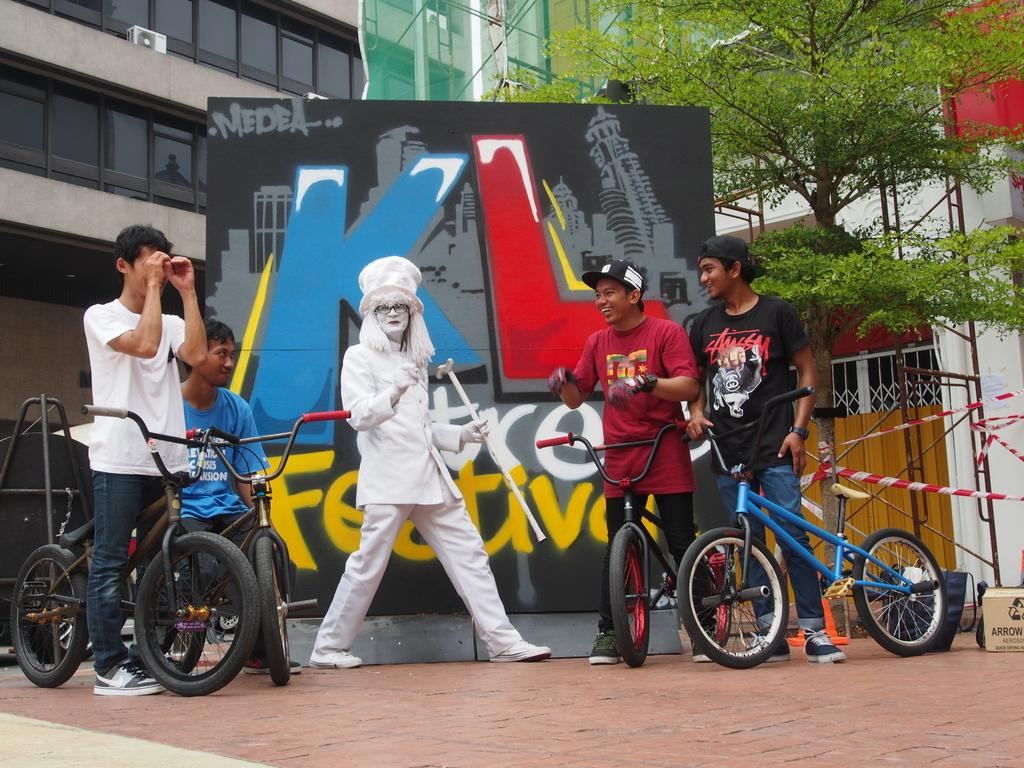What is happening in the image involving a bicycle? There are guys on a bicycle in the image. Can you describe the lady in the image? The lady in the image is wearing a white coat. What else can be seen in the image besides the people and bicycle? There is a poster in the image. What is the name of the poster? The poster is named "KL". How many celery stalks are being held by the lady in the image? There is no celery present in the image. Can you tell me if the lady's friend is also in the image? The provided facts do not mention any friends, so we cannot determine if the lady has a friend in the image. 